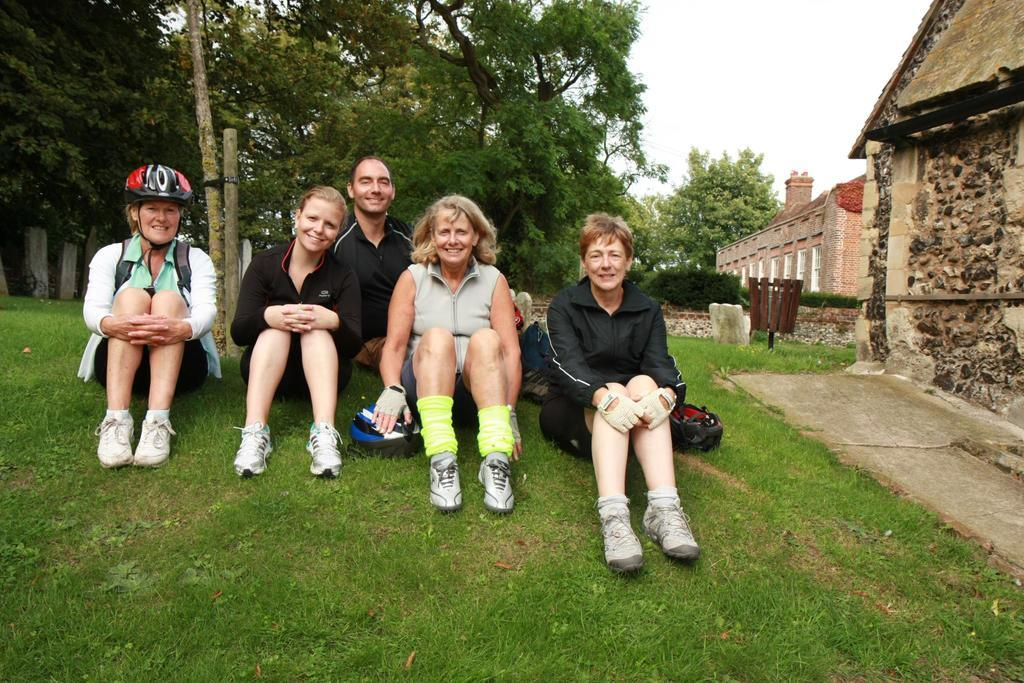How many people are in the image? There is one man and four women in the image. What are they sitting on? They are sitting on grassy land. What can be seen in the background of the image? There are trees, a bamboo pole, and houses in the background of the image. What type of cork can be seen floating in the water in the image? There is no water or cork present in the image; it features people sitting on grassy land with trees, a bamboo pole, and houses in the background. 